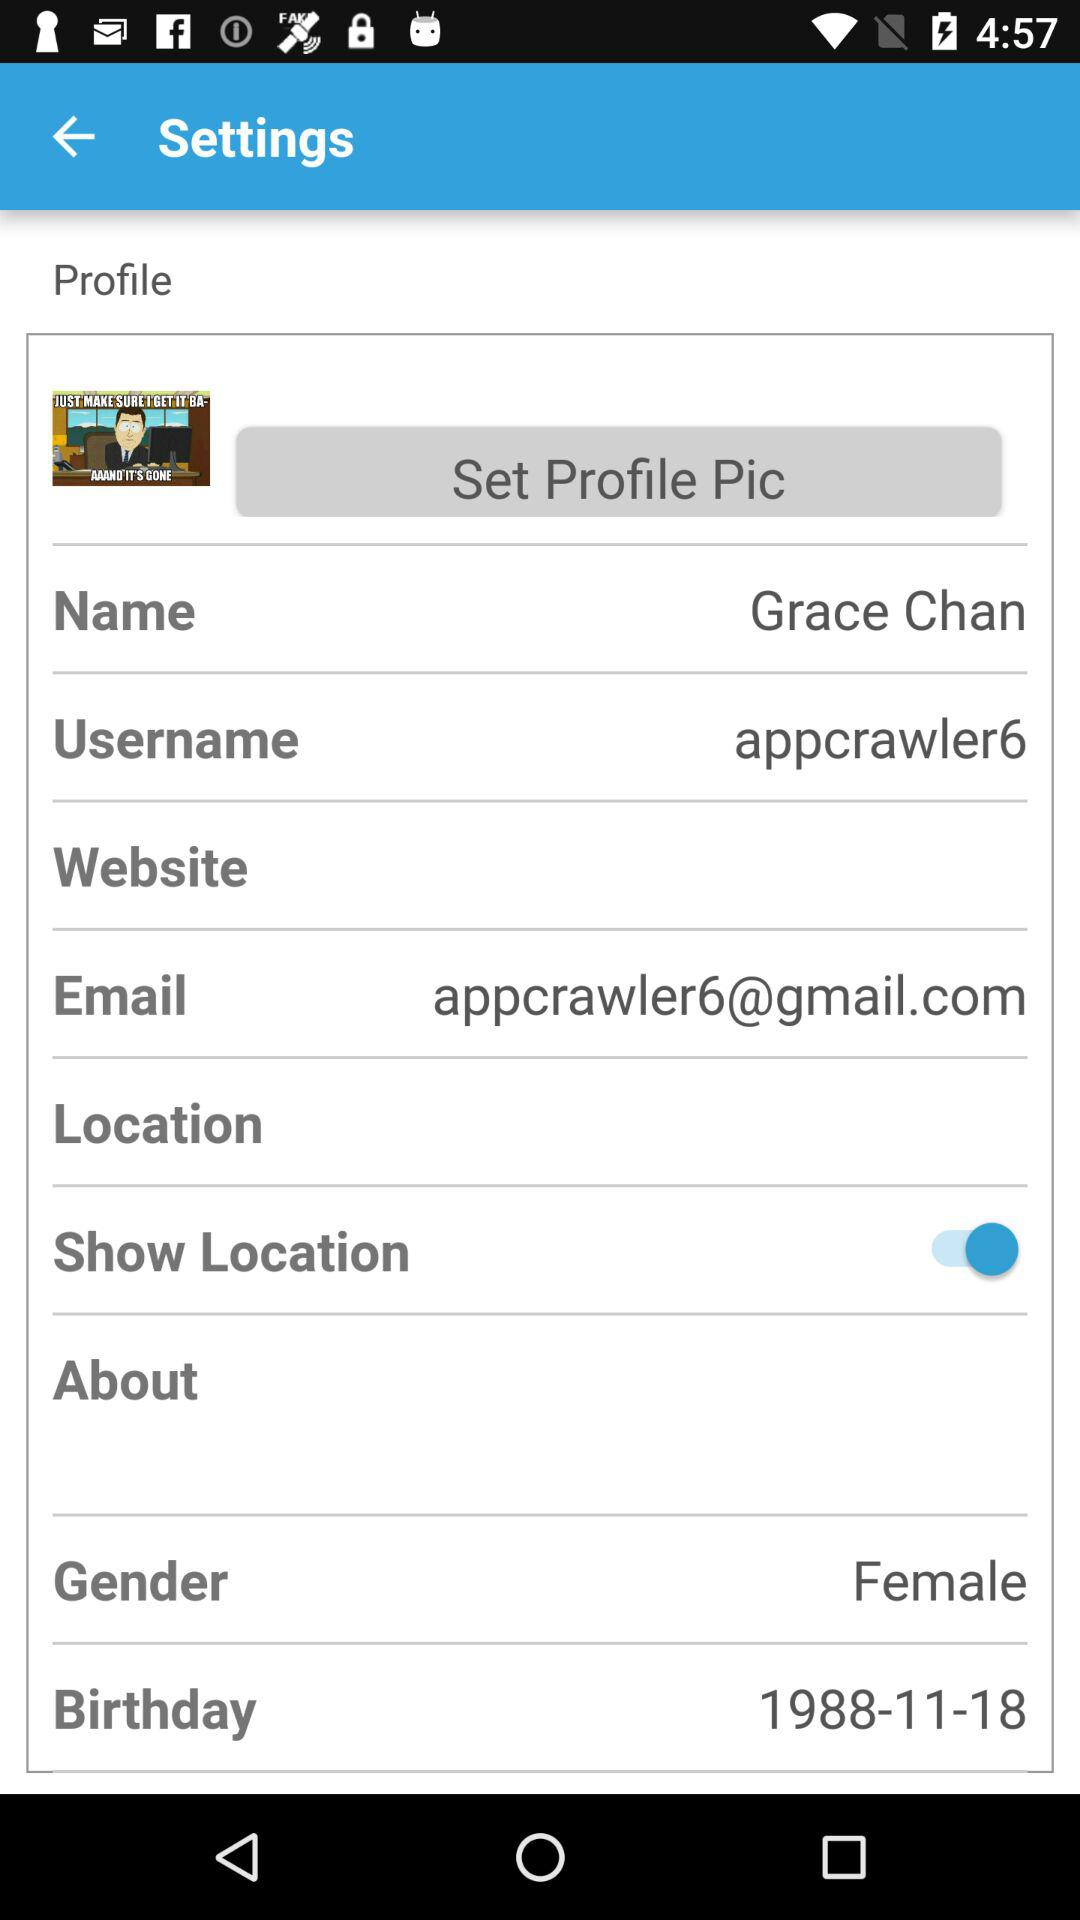What is the name? The name is Grace Chan. 